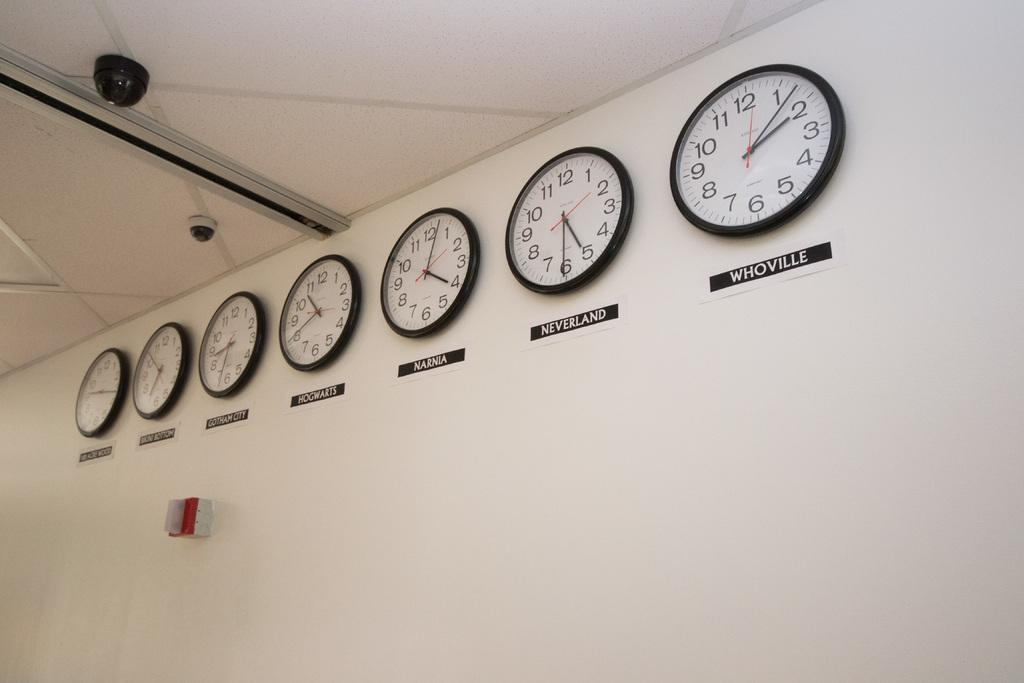<image>
Present a compact description of the photo's key features. several clocks on the wall one of which is for Whoville 